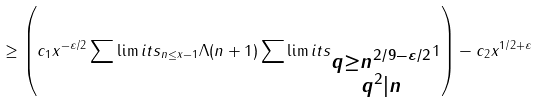<formula> <loc_0><loc_0><loc_500><loc_500>\geq \left ( c _ { 1 } x ^ { - \varepsilon / 2 } \sum \lim i t s _ { n \leq x - 1 } \Lambda ( n + 1 ) \sum \lim i t s _ { \substack { q \geq n ^ { 2 / 9 - \varepsilon / 2 } \\ q ^ { 2 } | n } } 1 \right ) - c _ { 2 } x ^ { 1 / 2 + \varepsilon }</formula> 